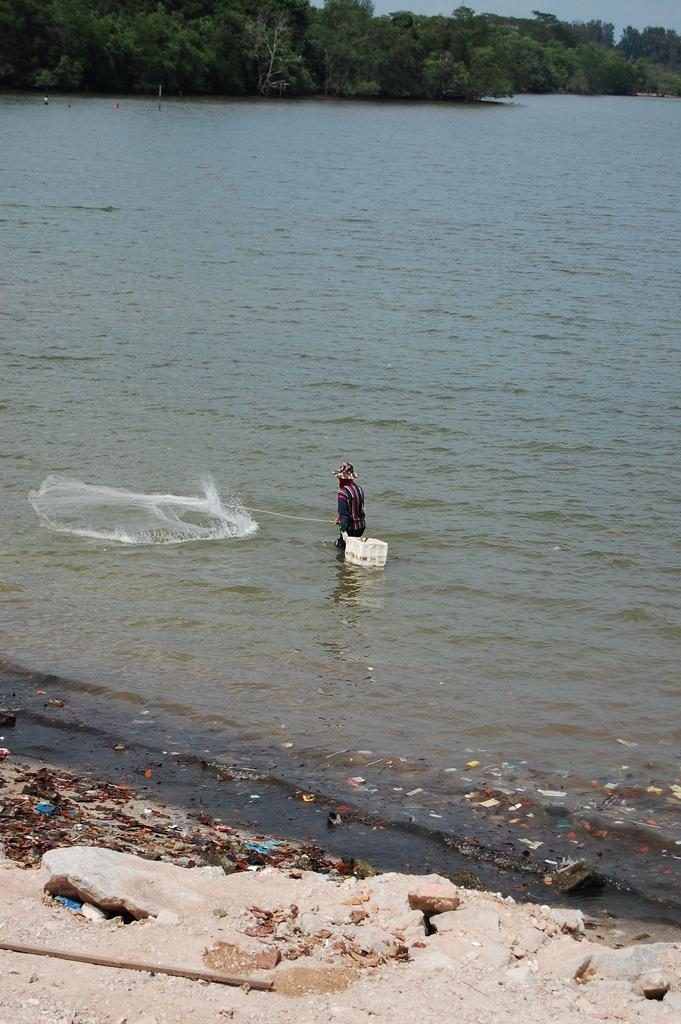What is the man in the image doing? The man is in the water and holding a net. What might the man be trying to catch or collect with the net? It is not explicitly stated, but the man could be trying to catch fish or collect something from the water. What can be seen in the background of the image? Trees are visible at the top of the image. What type of flowers can be seen growing near the man in the image? There are no flowers visible in the image; it features a man in the water holding a net and trees in the background. 